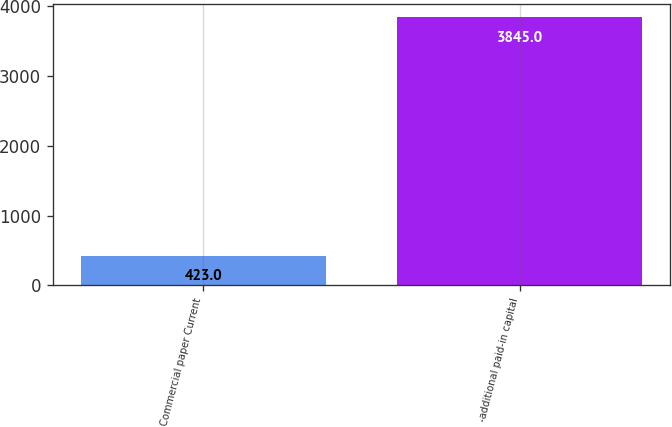Convert chart. <chart><loc_0><loc_0><loc_500><loc_500><bar_chart><fcel>Commercial paper Current<fcel>-additional paid-in capital<nl><fcel>423<fcel>3845<nl></chart> 